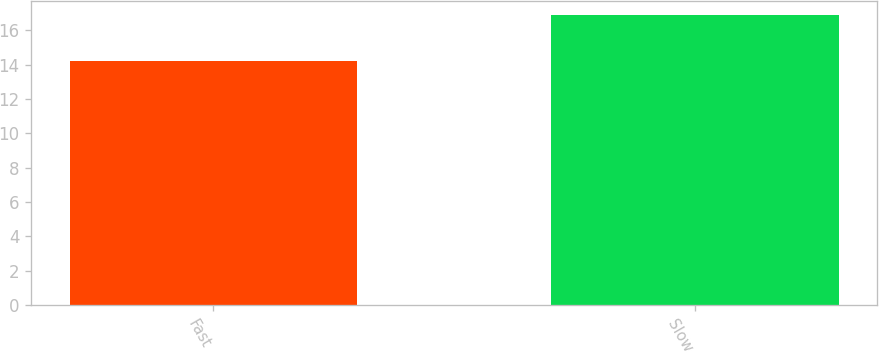<chart> <loc_0><loc_0><loc_500><loc_500><bar_chart><fcel>Fast<fcel>Slow<nl><fcel>14.2<fcel>16.9<nl></chart> 